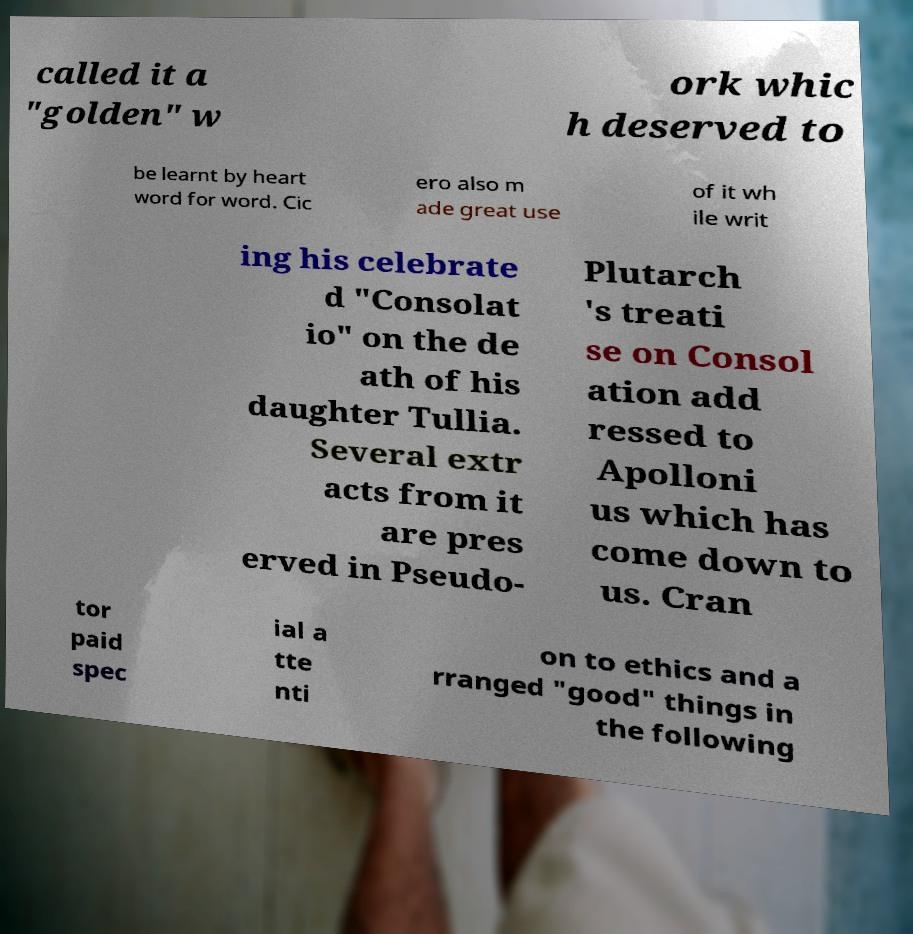Can you read and provide the text displayed in the image?This photo seems to have some interesting text. Can you extract and type it out for me? called it a "golden" w ork whic h deserved to be learnt by heart word for word. Cic ero also m ade great use of it wh ile writ ing his celebrate d "Consolat io" on the de ath of his daughter Tullia. Several extr acts from it are pres erved in Pseudo- Plutarch 's treati se on Consol ation add ressed to Apolloni us which has come down to us. Cran tor paid spec ial a tte nti on to ethics and a rranged "good" things in the following 